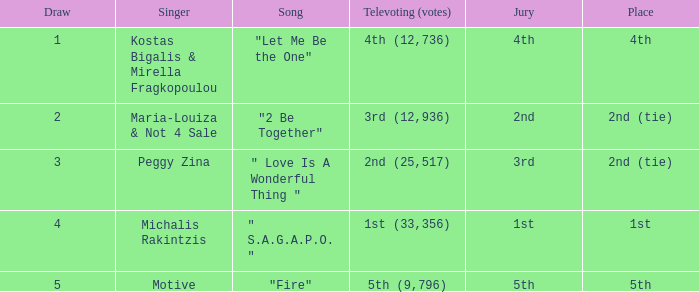The song "2 Be Together" had what jury? 2nd. 